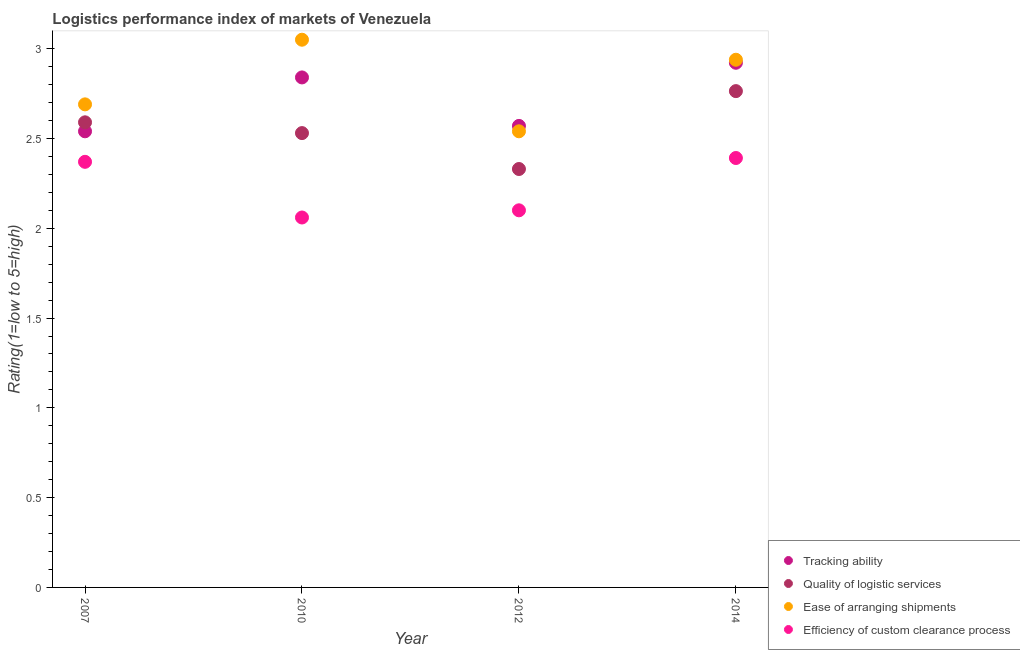How many different coloured dotlines are there?
Offer a very short reply. 4. What is the lpi rating of ease of arranging shipments in 2007?
Keep it short and to the point. 2.69. Across all years, what is the maximum lpi rating of quality of logistic services?
Offer a very short reply. 2.76. Across all years, what is the minimum lpi rating of ease of arranging shipments?
Your answer should be very brief. 2.54. What is the total lpi rating of tracking ability in the graph?
Provide a short and direct response. 10.87. What is the difference between the lpi rating of efficiency of custom clearance process in 2010 and that in 2012?
Ensure brevity in your answer.  -0.04. What is the difference between the lpi rating of tracking ability in 2010 and the lpi rating of ease of arranging shipments in 2014?
Offer a very short reply. -0.1. What is the average lpi rating of quality of logistic services per year?
Your answer should be very brief. 2.55. In the year 2010, what is the difference between the lpi rating of efficiency of custom clearance process and lpi rating of ease of arranging shipments?
Provide a short and direct response. -0.99. What is the ratio of the lpi rating of efficiency of custom clearance process in 2012 to that in 2014?
Offer a very short reply. 0.88. Is the lpi rating of quality of logistic services in 2007 less than that in 2012?
Provide a succinct answer. No. What is the difference between the highest and the second highest lpi rating of quality of logistic services?
Give a very brief answer. 0.17. What is the difference between the highest and the lowest lpi rating of quality of logistic services?
Your response must be concise. 0.43. In how many years, is the lpi rating of quality of logistic services greater than the average lpi rating of quality of logistic services taken over all years?
Provide a short and direct response. 2. Is the sum of the lpi rating of efficiency of custom clearance process in 2007 and 2014 greater than the maximum lpi rating of tracking ability across all years?
Give a very brief answer. Yes. Is the lpi rating of efficiency of custom clearance process strictly greater than the lpi rating of ease of arranging shipments over the years?
Ensure brevity in your answer.  No. Is the lpi rating of tracking ability strictly less than the lpi rating of efficiency of custom clearance process over the years?
Your answer should be very brief. No. How many years are there in the graph?
Your answer should be very brief. 4. Does the graph contain any zero values?
Your response must be concise. No. Does the graph contain grids?
Ensure brevity in your answer.  No. How many legend labels are there?
Provide a succinct answer. 4. What is the title of the graph?
Offer a very short reply. Logistics performance index of markets of Venezuela. Does "SF6 gas" appear as one of the legend labels in the graph?
Your answer should be very brief. No. What is the label or title of the X-axis?
Give a very brief answer. Year. What is the label or title of the Y-axis?
Keep it short and to the point. Rating(1=low to 5=high). What is the Rating(1=low to 5=high) of Tracking ability in 2007?
Provide a short and direct response. 2.54. What is the Rating(1=low to 5=high) in Quality of logistic services in 2007?
Your response must be concise. 2.59. What is the Rating(1=low to 5=high) of Ease of arranging shipments in 2007?
Make the answer very short. 2.69. What is the Rating(1=low to 5=high) of Efficiency of custom clearance process in 2007?
Ensure brevity in your answer.  2.37. What is the Rating(1=low to 5=high) in Tracking ability in 2010?
Provide a succinct answer. 2.84. What is the Rating(1=low to 5=high) of Quality of logistic services in 2010?
Your answer should be very brief. 2.53. What is the Rating(1=low to 5=high) of Ease of arranging shipments in 2010?
Provide a short and direct response. 3.05. What is the Rating(1=low to 5=high) of Efficiency of custom clearance process in 2010?
Keep it short and to the point. 2.06. What is the Rating(1=low to 5=high) of Tracking ability in 2012?
Provide a short and direct response. 2.57. What is the Rating(1=low to 5=high) of Quality of logistic services in 2012?
Offer a terse response. 2.33. What is the Rating(1=low to 5=high) in Ease of arranging shipments in 2012?
Ensure brevity in your answer.  2.54. What is the Rating(1=low to 5=high) of Tracking ability in 2014?
Your response must be concise. 2.92. What is the Rating(1=low to 5=high) of Quality of logistic services in 2014?
Ensure brevity in your answer.  2.76. What is the Rating(1=low to 5=high) of Ease of arranging shipments in 2014?
Your response must be concise. 2.94. What is the Rating(1=low to 5=high) in Efficiency of custom clearance process in 2014?
Your answer should be very brief. 2.39. Across all years, what is the maximum Rating(1=low to 5=high) in Tracking ability?
Make the answer very short. 2.92. Across all years, what is the maximum Rating(1=low to 5=high) of Quality of logistic services?
Give a very brief answer. 2.76. Across all years, what is the maximum Rating(1=low to 5=high) of Ease of arranging shipments?
Your response must be concise. 3.05. Across all years, what is the maximum Rating(1=low to 5=high) in Efficiency of custom clearance process?
Make the answer very short. 2.39. Across all years, what is the minimum Rating(1=low to 5=high) in Tracking ability?
Offer a very short reply. 2.54. Across all years, what is the minimum Rating(1=low to 5=high) in Quality of logistic services?
Your answer should be very brief. 2.33. Across all years, what is the minimum Rating(1=low to 5=high) of Ease of arranging shipments?
Offer a terse response. 2.54. Across all years, what is the minimum Rating(1=low to 5=high) in Efficiency of custom clearance process?
Provide a short and direct response. 2.06. What is the total Rating(1=low to 5=high) in Tracking ability in the graph?
Ensure brevity in your answer.  10.87. What is the total Rating(1=low to 5=high) in Quality of logistic services in the graph?
Your response must be concise. 10.21. What is the total Rating(1=low to 5=high) of Ease of arranging shipments in the graph?
Your response must be concise. 11.22. What is the total Rating(1=low to 5=high) in Efficiency of custom clearance process in the graph?
Offer a very short reply. 8.92. What is the difference between the Rating(1=low to 5=high) in Tracking ability in 2007 and that in 2010?
Make the answer very short. -0.3. What is the difference between the Rating(1=low to 5=high) of Quality of logistic services in 2007 and that in 2010?
Your response must be concise. 0.06. What is the difference between the Rating(1=low to 5=high) of Ease of arranging shipments in 2007 and that in 2010?
Ensure brevity in your answer.  -0.36. What is the difference between the Rating(1=low to 5=high) in Efficiency of custom clearance process in 2007 and that in 2010?
Your answer should be compact. 0.31. What is the difference between the Rating(1=low to 5=high) of Tracking ability in 2007 and that in 2012?
Your answer should be very brief. -0.03. What is the difference between the Rating(1=low to 5=high) in Quality of logistic services in 2007 and that in 2012?
Offer a terse response. 0.26. What is the difference between the Rating(1=low to 5=high) of Efficiency of custom clearance process in 2007 and that in 2012?
Provide a succinct answer. 0.27. What is the difference between the Rating(1=low to 5=high) of Tracking ability in 2007 and that in 2014?
Provide a succinct answer. -0.38. What is the difference between the Rating(1=low to 5=high) in Quality of logistic services in 2007 and that in 2014?
Your answer should be compact. -0.17. What is the difference between the Rating(1=low to 5=high) in Ease of arranging shipments in 2007 and that in 2014?
Ensure brevity in your answer.  -0.25. What is the difference between the Rating(1=low to 5=high) of Efficiency of custom clearance process in 2007 and that in 2014?
Offer a very short reply. -0.02. What is the difference between the Rating(1=low to 5=high) of Tracking ability in 2010 and that in 2012?
Provide a succinct answer. 0.27. What is the difference between the Rating(1=low to 5=high) of Ease of arranging shipments in 2010 and that in 2012?
Your answer should be very brief. 0.51. What is the difference between the Rating(1=low to 5=high) in Efficiency of custom clearance process in 2010 and that in 2012?
Provide a succinct answer. -0.04. What is the difference between the Rating(1=low to 5=high) of Tracking ability in 2010 and that in 2014?
Your response must be concise. -0.08. What is the difference between the Rating(1=low to 5=high) of Quality of logistic services in 2010 and that in 2014?
Offer a very short reply. -0.23. What is the difference between the Rating(1=low to 5=high) in Ease of arranging shipments in 2010 and that in 2014?
Make the answer very short. 0.11. What is the difference between the Rating(1=low to 5=high) in Efficiency of custom clearance process in 2010 and that in 2014?
Offer a very short reply. -0.33. What is the difference between the Rating(1=low to 5=high) in Tracking ability in 2012 and that in 2014?
Offer a very short reply. -0.35. What is the difference between the Rating(1=low to 5=high) of Quality of logistic services in 2012 and that in 2014?
Ensure brevity in your answer.  -0.43. What is the difference between the Rating(1=low to 5=high) of Ease of arranging shipments in 2012 and that in 2014?
Offer a terse response. -0.4. What is the difference between the Rating(1=low to 5=high) of Efficiency of custom clearance process in 2012 and that in 2014?
Ensure brevity in your answer.  -0.29. What is the difference between the Rating(1=low to 5=high) in Tracking ability in 2007 and the Rating(1=low to 5=high) in Ease of arranging shipments in 2010?
Give a very brief answer. -0.51. What is the difference between the Rating(1=low to 5=high) of Tracking ability in 2007 and the Rating(1=low to 5=high) of Efficiency of custom clearance process in 2010?
Offer a very short reply. 0.48. What is the difference between the Rating(1=low to 5=high) in Quality of logistic services in 2007 and the Rating(1=low to 5=high) in Ease of arranging shipments in 2010?
Your answer should be compact. -0.46. What is the difference between the Rating(1=low to 5=high) in Quality of logistic services in 2007 and the Rating(1=low to 5=high) in Efficiency of custom clearance process in 2010?
Provide a succinct answer. 0.53. What is the difference between the Rating(1=low to 5=high) in Ease of arranging shipments in 2007 and the Rating(1=low to 5=high) in Efficiency of custom clearance process in 2010?
Make the answer very short. 0.63. What is the difference between the Rating(1=low to 5=high) of Tracking ability in 2007 and the Rating(1=low to 5=high) of Quality of logistic services in 2012?
Offer a terse response. 0.21. What is the difference between the Rating(1=low to 5=high) in Tracking ability in 2007 and the Rating(1=low to 5=high) in Efficiency of custom clearance process in 2012?
Your answer should be compact. 0.44. What is the difference between the Rating(1=low to 5=high) in Quality of logistic services in 2007 and the Rating(1=low to 5=high) in Efficiency of custom clearance process in 2012?
Ensure brevity in your answer.  0.49. What is the difference between the Rating(1=low to 5=high) in Ease of arranging shipments in 2007 and the Rating(1=low to 5=high) in Efficiency of custom clearance process in 2012?
Make the answer very short. 0.59. What is the difference between the Rating(1=low to 5=high) in Tracking ability in 2007 and the Rating(1=low to 5=high) in Quality of logistic services in 2014?
Your answer should be very brief. -0.22. What is the difference between the Rating(1=low to 5=high) in Tracking ability in 2007 and the Rating(1=low to 5=high) in Ease of arranging shipments in 2014?
Your answer should be compact. -0.4. What is the difference between the Rating(1=low to 5=high) in Tracking ability in 2007 and the Rating(1=low to 5=high) in Efficiency of custom clearance process in 2014?
Ensure brevity in your answer.  0.15. What is the difference between the Rating(1=low to 5=high) of Quality of logistic services in 2007 and the Rating(1=low to 5=high) of Ease of arranging shipments in 2014?
Make the answer very short. -0.35. What is the difference between the Rating(1=low to 5=high) in Quality of logistic services in 2007 and the Rating(1=low to 5=high) in Efficiency of custom clearance process in 2014?
Offer a very short reply. 0.2. What is the difference between the Rating(1=low to 5=high) in Ease of arranging shipments in 2007 and the Rating(1=low to 5=high) in Efficiency of custom clearance process in 2014?
Offer a very short reply. 0.3. What is the difference between the Rating(1=low to 5=high) in Tracking ability in 2010 and the Rating(1=low to 5=high) in Quality of logistic services in 2012?
Your response must be concise. 0.51. What is the difference between the Rating(1=low to 5=high) of Tracking ability in 2010 and the Rating(1=low to 5=high) of Efficiency of custom clearance process in 2012?
Provide a short and direct response. 0.74. What is the difference between the Rating(1=low to 5=high) in Quality of logistic services in 2010 and the Rating(1=low to 5=high) in Ease of arranging shipments in 2012?
Keep it short and to the point. -0.01. What is the difference between the Rating(1=low to 5=high) of Quality of logistic services in 2010 and the Rating(1=low to 5=high) of Efficiency of custom clearance process in 2012?
Your response must be concise. 0.43. What is the difference between the Rating(1=low to 5=high) in Ease of arranging shipments in 2010 and the Rating(1=low to 5=high) in Efficiency of custom clearance process in 2012?
Offer a very short reply. 0.95. What is the difference between the Rating(1=low to 5=high) in Tracking ability in 2010 and the Rating(1=low to 5=high) in Quality of logistic services in 2014?
Ensure brevity in your answer.  0.08. What is the difference between the Rating(1=low to 5=high) of Tracking ability in 2010 and the Rating(1=low to 5=high) of Ease of arranging shipments in 2014?
Provide a short and direct response. -0.1. What is the difference between the Rating(1=low to 5=high) in Tracking ability in 2010 and the Rating(1=low to 5=high) in Efficiency of custom clearance process in 2014?
Keep it short and to the point. 0.45. What is the difference between the Rating(1=low to 5=high) of Quality of logistic services in 2010 and the Rating(1=low to 5=high) of Ease of arranging shipments in 2014?
Provide a succinct answer. -0.41. What is the difference between the Rating(1=low to 5=high) of Quality of logistic services in 2010 and the Rating(1=low to 5=high) of Efficiency of custom clearance process in 2014?
Your response must be concise. 0.14. What is the difference between the Rating(1=low to 5=high) of Ease of arranging shipments in 2010 and the Rating(1=low to 5=high) of Efficiency of custom clearance process in 2014?
Provide a succinct answer. 0.66. What is the difference between the Rating(1=low to 5=high) of Tracking ability in 2012 and the Rating(1=low to 5=high) of Quality of logistic services in 2014?
Give a very brief answer. -0.19. What is the difference between the Rating(1=low to 5=high) in Tracking ability in 2012 and the Rating(1=low to 5=high) in Ease of arranging shipments in 2014?
Your answer should be very brief. -0.37. What is the difference between the Rating(1=low to 5=high) in Tracking ability in 2012 and the Rating(1=low to 5=high) in Efficiency of custom clearance process in 2014?
Ensure brevity in your answer.  0.18. What is the difference between the Rating(1=low to 5=high) of Quality of logistic services in 2012 and the Rating(1=low to 5=high) of Ease of arranging shipments in 2014?
Make the answer very short. -0.61. What is the difference between the Rating(1=low to 5=high) of Quality of logistic services in 2012 and the Rating(1=low to 5=high) of Efficiency of custom clearance process in 2014?
Provide a succinct answer. -0.06. What is the difference between the Rating(1=low to 5=high) of Ease of arranging shipments in 2012 and the Rating(1=low to 5=high) of Efficiency of custom clearance process in 2014?
Provide a succinct answer. 0.15. What is the average Rating(1=low to 5=high) of Tracking ability per year?
Ensure brevity in your answer.  2.72. What is the average Rating(1=low to 5=high) of Quality of logistic services per year?
Your answer should be very brief. 2.55. What is the average Rating(1=low to 5=high) in Ease of arranging shipments per year?
Make the answer very short. 2.8. What is the average Rating(1=low to 5=high) of Efficiency of custom clearance process per year?
Offer a very short reply. 2.23. In the year 2007, what is the difference between the Rating(1=low to 5=high) in Tracking ability and Rating(1=low to 5=high) in Quality of logistic services?
Offer a very short reply. -0.05. In the year 2007, what is the difference between the Rating(1=low to 5=high) of Tracking ability and Rating(1=low to 5=high) of Efficiency of custom clearance process?
Offer a terse response. 0.17. In the year 2007, what is the difference between the Rating(1=low to 5=high) in Quality of logistic services and Rating(1=low to 5=high) in Ease of arranging shipments?
Ensure brevity in your answer.  -0.1. In the year 2007, what is the difference between the Rating(1=low to 5=high) of Quality of logistic services and Rating(1=low to 5=high) of Efficiency of custom clearance process?
Your answer should be compact. 0.22. In the year 2007, what is the difference between the Rating(1=low to 5=high) in Ease of arranging shipments and Rating(1=low to 5=high) in Efficiency of custom clearance process?
Give a very brief answer. 0.32. In the year 2010, what is the difference between the Rating(1=low to 5=high) in Tracking ability and Rating(1=low to 5=high) in Quality of logistic services?
Your response must be concise. 0.31. In the year 2010, what is the difference between the Rating(1=low to 5=high) in Tracking ability and Rating(1=low to 5=high) in Ease of arranging shipments?
Your answer should be compact. -0.21. In the year 2010, what is the difference between the Rating(1=low to 5=high) in Tracking ability and Rating(1=low to 5=high) in Efficiency of custom clearance process?
Your response must be concise. 0.78. In the year 2010, what is the difference between the Rating(1=low to 5=high) in Quality of logistic services and Rating(1=low to 5=high) in Ease of arranging shipments?
Offer a terse response. -0.52. In the year 2010, what is the difference between the Rating(1=low to 5=high) in Quality of logistic services and Rating(1=low to 5=high) in Efficiency of custom clearance process?
Provide a short and direct response. 0.47. In the year 2012, what is the difference between the Rating(1=low to 5=high) in Tracking ability and Rating(1=low to 5=high) in Quality of logistic services?
Ensure brevity in your answer.  0.24. In the year 2012, what is the difference between the Rating(1=low to 5=high) in Tracking ability and Rating(1=low to 5=high) in Efficiency of custom clearance process?
Your response must be concise. 0.47. In the year 2012, what is the difference between the Rating(1=low to 5=high) of Quality of logistic services and Rating(1=low to 5=high) of Ease of arranging shipments?
Give a very brief answer. -0.21. In the year 2012, what is the difference between the Rating(1=low to 5=high) in Quality of logistic services and Rating(1=low to 5=high) in Efficiency of custom clearance process?
Your response must be concise. 0.23. In the year 2012, what is the difference between the Rating(1=low to 5=high) in Ease of arranging shipments and Rating(1=low to 5=high) in Efficiency of custom clearance process?
Your answer should be compact. 0.44. In the year 2014, what is the difference between the Rating(1=low to 5=high) of Tracking ability and Rating(1=low to 5=high) of Quality of logistic services?
Offer a terse response. 0.16. In the year 2014, what is the difference between the Rating(1=low to 5=high) in Tracking ability and Rating(1=low to 5=high) in Ease of arranging shipments?
Provide a succinct answer. -0.02. In the year 2014, what is the difference between the Rating(1=low to 5=high) in Tracking ability and Rating(1=low to 5=high) in Efficiency of custom clearance process?
Your response must be concise. 0.53. In the year 2014, what is the difference between the Rating(1=low to 5=high) of Quality of logistic services and Rating(1=low to 5=high) of Ease of arranging shipments?
Keep it short and to the point. -0.17. In the year 2014, what is the difference between the Rating(1=low to 5=high) of Quality of logistic services and Rating(1=low to 5=high) of Efficiency of custom clearance process?
Offer a very short reply. 0.37. In the year 2014, what is the difference between the Rating(1=low to 5=high) in Ease of arranging shipments and Rating(1=low to 5=high) in Efficiency of custom clearance process?
Keep it short and to the point. 0.55. What is the ratio of the Rating(1=low to 5=high) of Tracking ability in 2007 to that in 2010?
Provide a short and direct response. 0.89. What is the ratio of the Rating(1=low to 5=high) of Quality of logistic services in 2007 to that in 2010?
Ensure brevity in your answer.  1.02. What is the ratio of the Rating(1=low to 5=high) in Ease of arranging shipments in 2007 to that in 2010?
Make the answer very short. 0.88. What is the ratio of the Rating(1=low to 5=high) in Efficiency of custom clearance process in 2007 to that in 2010?
Your answer should be compact. 1.15. What is the ratio of the Rating(1=low to 5=high) of Tracking ability in 2007 to that in 2012?
Provide a short and direct response. 0.99. What is the ratio of the Rating(1=low to 5=high) of Quality of logistic services in 2007 to that in 2012?
Keep it short and to the point. 1.11. What is the ratio of the Rating(1=low to 5=high) of Ease of arranging shipments in 2007 to that in 2012?
Offer a terse response. 1.06. What is the ratio of the Rating(1=low to 5=high) of Efficiency of custom clearance process in 2007 to that in 2012?
Give a very brief answer. 1.13. What is the ratio of the Rating(1=low to 5=high) of Tracking ability in 2007 to that in 2014?
Offer a terse response. 0.87. What is the ratio of the Rating(1=low to 5=high) in Quality of logistic services in 2007 to that in 2014?
Make the answer very short. 0.94. What is the ratio of the Rating(1=low to 5=high) in Ease of arranging shipments in 2007 to that in 2014?
Your answer should be very brief. 0.92. What is the ratio of the Rating(1=low to 5=high) of Tracking ability in 2010 to that in 2012?
Provide a short and direct response. 1.11. What is the ratio of the Rating(1=low to 5=high) in Quality of logistic services in 2010 to that in 2012?
Keep it short and to the point. 1.09. What is the ratio of the Rating(1=low to 5=high) of Ease of arranging shipments in 2010 to that in 2012?
Provide a succinct answer. 1.2. What is the ratio of the Rating(1=low to 5=high) of Efficiency of custom clearance process in 2010 to that in 2012?
Give a very brief answer. 0.98. What is the ratio of the Rating(1=low to 5=high) in Tracking ability in 2010 to that in 2014?
Your response must be concise. 0.97. What is the ratio of the Rating(1=low to 5=high) of Quality of logistic services in 2010 to that in 2014?
Provide a succinct answer. 0.92. What is the ratio of the Rating(1=low to 5=high) in Ease of arranging shipments in 2010 to that in 2014?
Keep it short and to the point. 1.04. What is the ratio of the Rating(1=low to 5=high) in Efficiency of custom clearance process in 2010 to that in 2014?
Offer a terse response. 0.86. What is the ratio of the Rating(1=low to 5=high) of Tracking ability in 2012 to that in 2014?
Your answer should be compact. 0.88. What is the ratio of the Rating(1=low to 5=high) in Quality of logistic services in 2012 to that in 2014?
Offer a terse response. 0.84. What is the ratio of the Rating(1=low to 5=high) in Ease of arranging shipments in 2012 to that in 2014?
Provide a short and direct response. 0.86. What is the ratio of the Rating(1=low to 5=high) in Efficiency of custom clearance process in 2012 to that in 2014?
Give a very brief answer. 0.88. What is the difference between the highest and the second highest Rating(1=low to 5=high) of Tracking ability?
Provide a succinct answer. 0.08. What is the difference between the highest and the second highest Rating(1=low to 5=high) in Quality of logistic services?
Your response must be concise. 0.17. What is the difference between the highest and the second highest Rating(1=low to 5=high) in Ease of arranging shipments?
Offer a terse response. 0.11. What is the difference between the highest and the second highest Rating(1=low to 5=high) of Efficiency of custom clearance process?
Offer a terse response. 0.02. What is the difference between the highest and the lowest Rating(1=low to 5=high) in Tracking ability?
Your response must be concise. 0.38. What is the difference between the highest and the lowest Rating(1=low to 5=high) of Quality of logistic services?
Offer a terse response. 0.43. What is the difference between the highest and the lowest Rating(1=low to 5=high) in Ease of arranging shipments?
Give a very brief answer. 0.51. What is the difference between the highest and the lowest Rating(1=low to 5=high) of Efficiency of custom clearance process?
Provide a short and direct response. 0.33. 